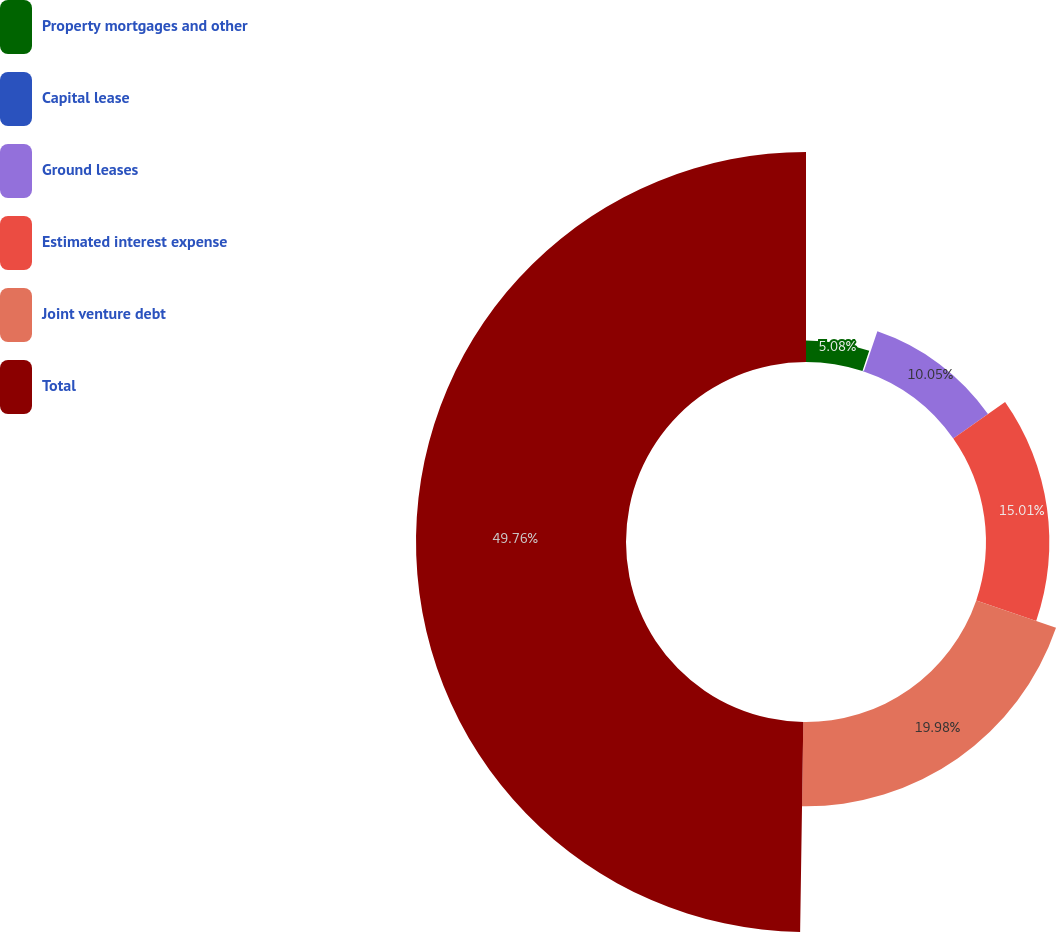<chart> <loc_0><loc_0><loc_500><loc_500><pie_chart><fcel>Property mortgages and other<fcel>Capital lease<fcel>Ground leases<fcel>Estimated interest expense<fcel>Joint venture debt<fcel>Total<nl><fcel>5.08%<fcel>0.12%<fcel>10.05%<fcel>15.01%<fcel>19.98%<fcel>49.76%<nl></chart> 